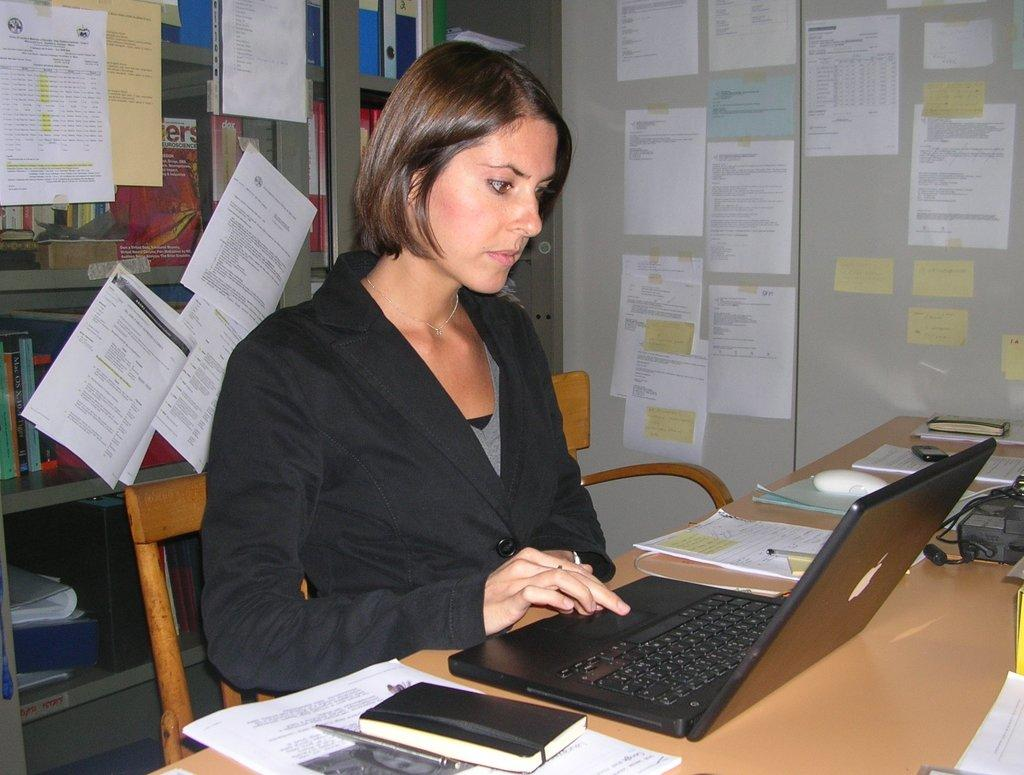<image>
Provide a brief description of the given image. A pink cover of book is on a shelf behind the woman and shows letters "ers." 